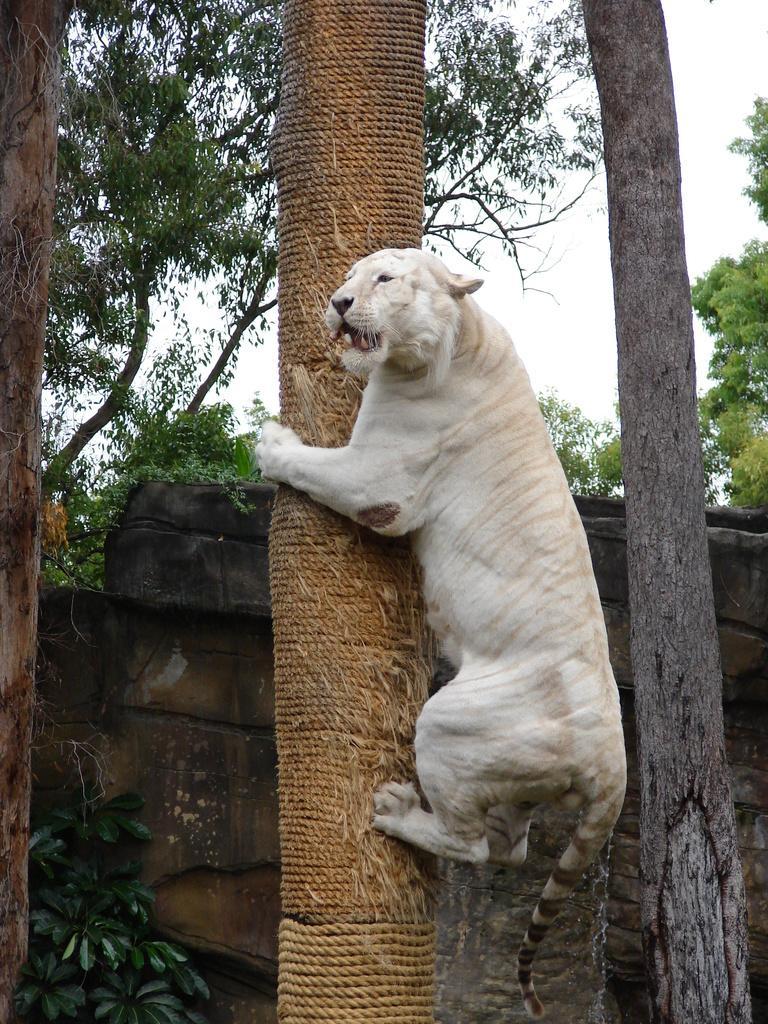Please provide a concise description of this image. In this image an animal is climbing the tree trunk which is tied with the ropes. Behind it there is a wall. Background there are few trees. Behind there is sky. Right side there is a tree trunk. Left bottom there is a plant. Beside there is a tree trunk. 